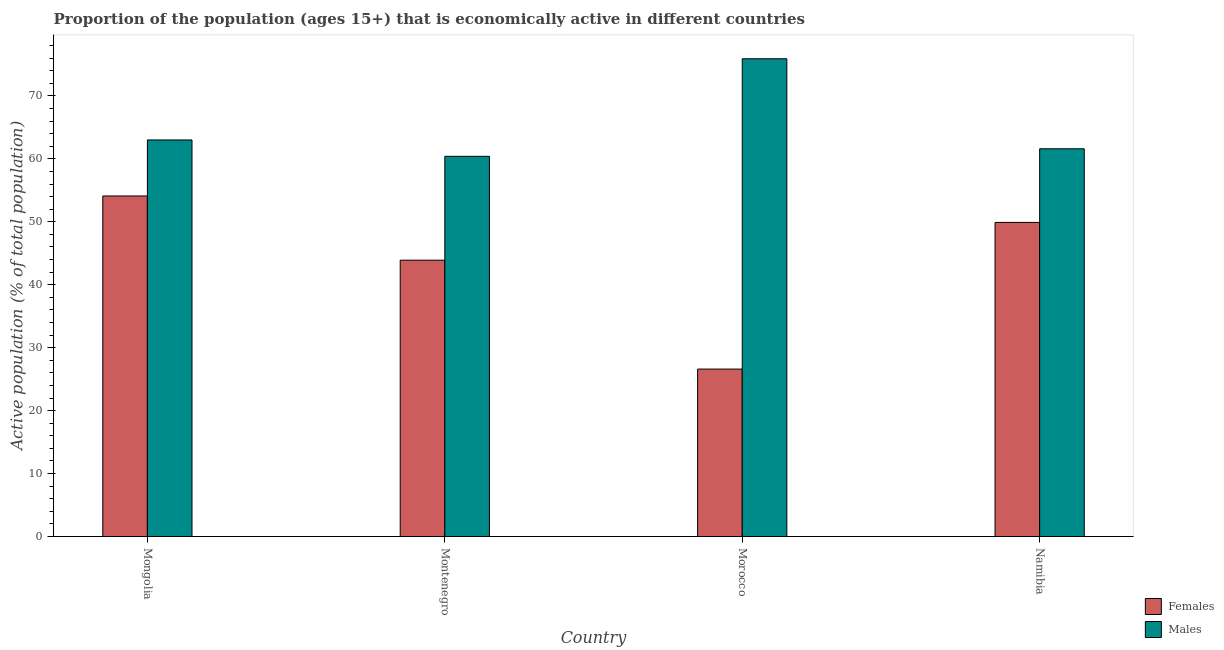Are the number of bars per tick equal to the number of legend labels?
Offer a terse response. Yes. Are the number of bars on each tick of the X-axis equal?
Provide a succinct answer. Yes. How many bars are there on the 2nd tick from the left?
Make the answer very short. 2. How many bars are there on the 4th tick from the right?
Give a very brief answer. 2. What is the label of the 3rd group of bars from the left?
Provide a succinct answer. Morocco. What is the percentage of economically active female population in Namibia?
Your response must be concise. 49.9. Across all countries, what is the maximum percentage of economically active male population?
Provide a succinct answer. 75.9. Across all countries, what is the minimum percentage of economically active male population?
Your response must be concise. 60.4. In which country was the percentage of economically active male population maximum?
Offer a very short reply. Morocco. In which country was the percentage of economically active male population minimum?
Ensure brevity in your answer.  Montenegro. What is the total percentage of economically active female population in the graph?
Provide a succinct answer. 174.5. What is the difference between the percentage of economically active male population in Mongolia and that in Namibia?
Ensure brevity in your answer.  1.4. What is the difference between the percentage of economically active female population in Morocco and the percentage of economically active male population in Mongolia?
Ensure brevity in your answer.  -36.4. What is the average percentage of economically active female population per country?
Offer a very short reply. 43.63. What is the difference between the percentage of economically active male population and percentage of economically active female population in Namibia?
Ensure brevity in your answer.  11.7. What is the ratio of the percentage of economically active female population in Mongolia to that in Namibia?
Your answer should be compact. 1.08. What is the difference between the highest and the second highest percentage of economically active male population?
Offer a very short reply. 12.9. What is the difference between the highest and the lowest percentage of economically active female population?
Give a very brief answer. 27.5. In how many countries, is the percentage of economically active female population greater than the average percentage of economically active female population taken over all countries?
Keep it short and to the point. 3. Is the sum of the percentage of economically active female population in Morocco and Namibia greater than the maximum percentage of economically active male population across all countries?
Offer a terse response. Yes. What does the 1st bar from the left in Morocco represents?
Offer a very short reply. Females. What does the 1st bar from the right in Morocco represents?
Your response must be concise. Males. How many bars are there?
Your response must be concise. 8. Are all the bars in the graph horizontal?
Offer a very short reply. No. How many countries are there in the graph?
Your answer should be very brief. 4. What is the difference between two consecutive major ticks on the Y-axis?
Offer a very short reply. 10. How many legend labels are there?
Ensure brevity in your answer.  2. What is the title of the graph?
Your response must be concise. Proportion of the population (ages 15+) that is economically active in different countries. What is the label or title of the X-axis?
Keep it short and to the point. Country. What is the label or title of the Y-axis?
Ensure brevity in your answer.  Active population (% of total population). What is the Active population (% of total population) in Females in Mongolia?
Ensure brevity in your answer.  54.1. What is the Active population (% of total population) in Females in Montenegro?
Provide a succinct answer. 43.9. What is the Active population (% of total population) in Males in Montenegro?
Give a very brief answer. 60.4. What is the Active population (% of total population) of Females in Morocco?
Make the answer very short. 26.6. What is the Active population (% of total population) in Males in Morocco?
Ensure brevity in your answer.  75.9. What is the Active population (% of total population) of Females in Namibia?
Offer a terse response. 49.9. What is the Active population (% of total population) of Males in Namibia?
Ensure brevity in your answer.  61.6. Across all countries, what is the maximum Active population (% of total population) of Females?
Your answer should be compact. 54.1. Across all countries, what is the maximum Active population (% of total population) of Males?
Offer a very short reply. 75.9. Across all countries, what is the minimum Active population (% of total population) of Females?
Ensure brevity in your answer.  26.6. Across all countries, what is the minimum Active population (% of total population) of Males?
Your answer should be very brief. 60.4. What is the total Active population (% of total population) in Females in the graph?
Ensure brevity in your answer.  174.5. What is the total Active population (% of total population) of Males in the graph?
Provide a short and direct response. 260.9. What is the difference between the Active population (% of total population) of Females in Mongolia and that in Montenegro?
Keep it short and to the point. 10.2. What is the difference between the Active population (% of total population) of Males in Montenegro and that in Morocco?
Offer a terse response. -15.5. What is the difference between the Active population (% of total population) in Males in Montenegro and that in Namibia?
Ensure brevity in your answer.  -1.2. What is the difference between the Active population (% of total population) in Females in Morocco and that in Namibia?
Keep it short and to the point. -23.3. What is the difference between the Active population (% of total population) in Males in Morocco and that in Namibia?
Provide a short and direct response. 14.3. What is the difference between the Active population (% of total population) of Females in Mongolia and the Active population (% of total population) of Males in Morocco?
Provide a succinct answer. -21.8. What is the difference between the Active population (% of total population) in Females in Montenegro and the Active population (% of total population) in Males in Morocco?
Give a very brief answer. -32. What is the difference between the Active population (% of total population) in Females in Montenegro and the Active population (% of total population) in Males in Namibia?
Offer a terse response. -17.7. What is the difference between the Active population (% of total population) of Females in Morocco and the Active population (% of total population) of Males in Namibia?
Your answer should be compact. -35. What is the average Active population (% of total population) of Females per country?
Ensure brevity in your answer.  43.62. What is the average Active population (% of total population) in Males per country?
Your response must be concise. 65.22. What is the difference between the Active population (% of total population) in Females and Active population (% of total population) in Males in Montenegro?
Make the answer very short. -16.5. What is the difference between the Active population (% of total population) in Females and Active population (% of total population) in Males in Morocco?
Your answer should be compact. -49.3. What is the difference between the Active population (% of total population) of Females and Active population (% of total population) of Males in Namibia?
Make the answer very short. -11.7. What is the ratio of the Active population (% of total population) of Females in Mongolia to that in Montenegro?
Offer a very short reply. 1.23. What is the ratio of the Active population (% of total population) of Males in Mongolia to that in Montenegro?
Your response must be concise. 1.04. What is the ratio of the Active population (% of total population) of Females in Mongolia to that in Morocco?
Give a very brief answer. 2.03. What is the ratio of the Active population (% of total population) in Males in Mongolia to that in Morocco?
Ensure brevity in your answer.  0.83. What is the ratio of the Active population (% of total population) in Females in Mongolia to that in Namibia?
Give a very brief answer. 1.08. What is the ratio of the Active population (% of total population) of Males in Mongolia to that in Namibia?
Offer a very short reply. 1.02. What is the ratio of the Active population (% of total population) in Females in Montenegro to that in Morocco?
Keep it short and to the point. 1.65. What is the ratio of the Active population (% of total population) in Males in Montenegro to that in Morocco?
Provide a short and direct response. 0.8. What is the ratio of the Active population (% of total population) in Females in Montenegro to that in Namibia?
Ensure brevity in your answer.  0.88. What is the ratio of the Active population (% of total population) of Males in Montenegro to that in Namibia?
Make the answer very short. 0.98. What is the ratio of the Active population (% of total population) in Females in Morocco to that in Namibia?
Keep it short and to the point. 0.53. What is the ratio of the Active population (% of total population) of Males in Morocco to that in Namibia?
Offer a very short reply. 1.23. What is the difference between the highest and the lowest Active population (% of total population) of Females?
Offer a very short reply. 27.5. What is the difference between the highest and the lowest Active population (% of total population) in Males?
Keep it short and to the point. 15.5. 